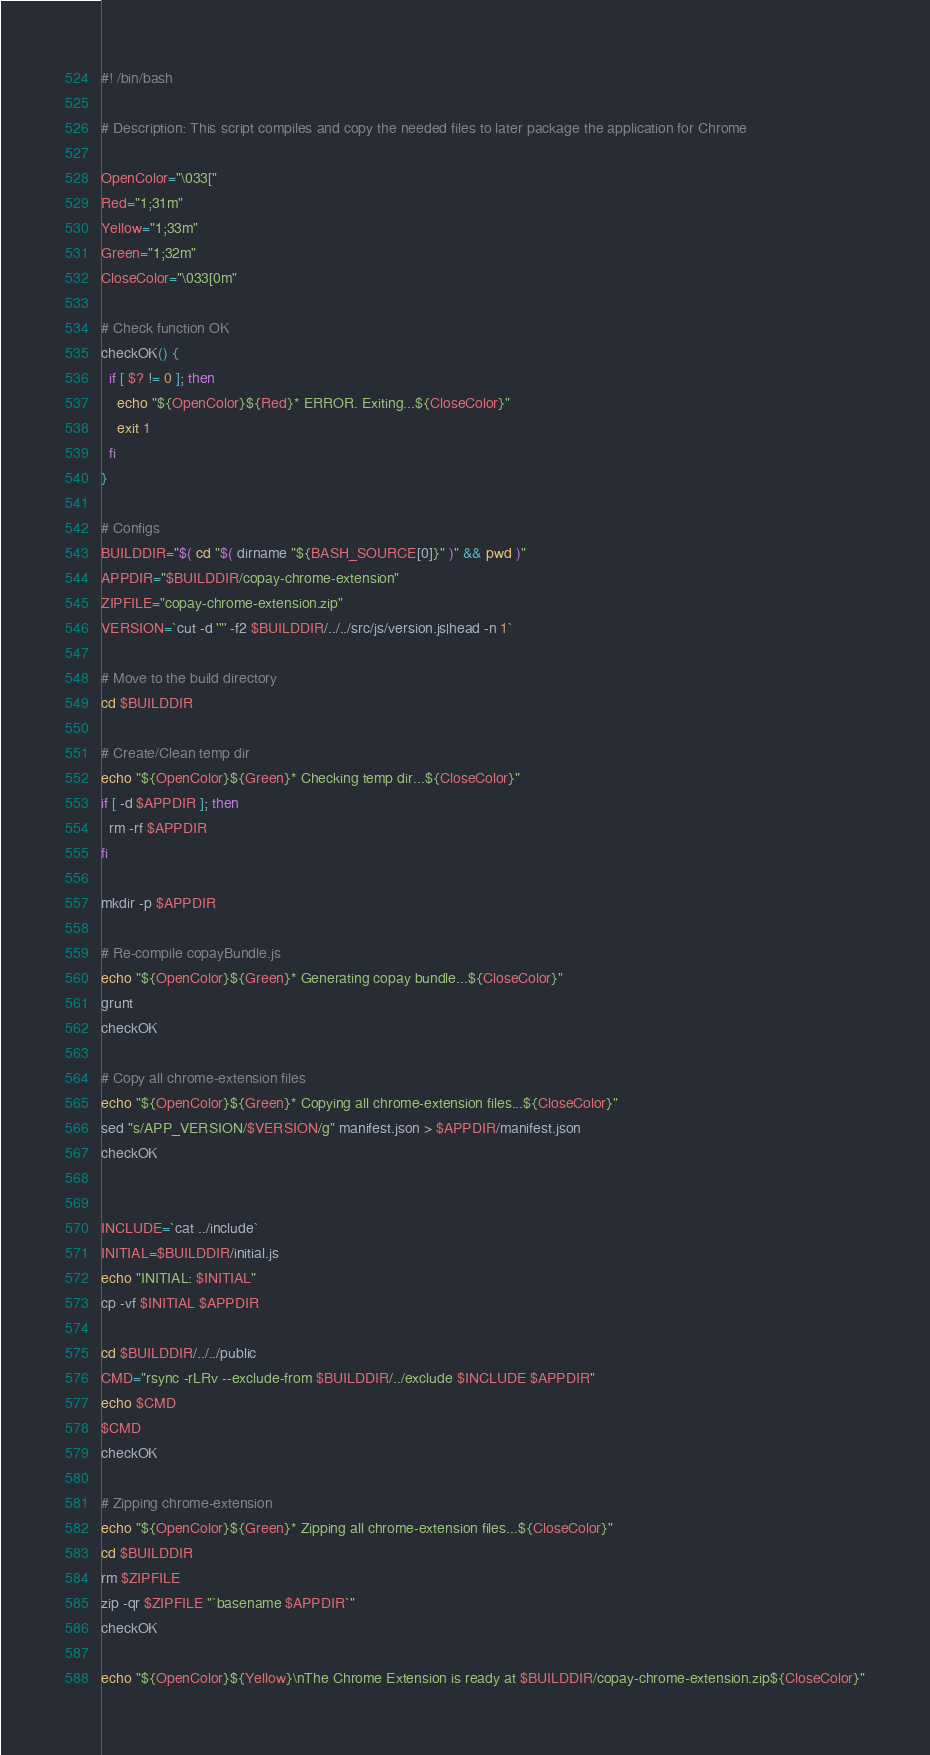<code> <loc_0><loc_0><loc_500><loc_500><_Bash_>#! /bin/bash

# Description: This script compiles and copy the needed files to later package the application for Chrome

OpenColor="\033["
Red="1;31m"
Yellow="1;33m"
Green="1;32m"
CloseColor="\033[0m"

# Check function OK
checkOK() {
  if [ $? != 0 ]; then
    echo "${OpenColor}${Red}* ERROR. Exiting...${CloseColor}"
    exit 1
  fi
}

# Configs
BUILDDIR="$( cd "$( dirname "${BASH_SOURCE[0]}" )" && pwd )"
APPDIR="$BUILDDIR/copay-chrome-extension"
ZIPFILE="copay-chrome-extension.zip"
VERSION=`cut -d '"' -f2 $BUILDDIR/../../src/js/version.js|head -n 1`

# Move to the build directory
cd $BUILDDIR

# Create/Clean temp dir
echo "${OpenColor}${Green}* Checking temp dir...${CloseColor}"
if [ -d $APPDIR ]; then
  rm -rf $APPDIR
fi

mkdir -p $APPDIR

# Re-compile copayBundle.js
echo "${OpenColor}${Green}* Generating copay bundle...${CloseColor}"
grunt
checkOK

# Copy all chrome-extension files
echo "${OpenColor}${Green}* Copying all chrome-extension files...${CloseColor}"
sed "s/APP_VERSION/$VERSION/g" manifest.json > $APPDIR/manifest.json
checkOK

 
INCLUDE=`cat ../include`
INITIAL=$BUILDDIR/initial.js
echo "INITIAL: $INITIAL"
cp -vf $INITIAL $APPDIR

cd $BUILDDIR/../../public
CMD="rsync -rLRv --exclude-from $BUILDDIR/../exclude $INCLUDE $APPDIR"
echo $CMD
$CMD
checkOK

# Zipping chrome-extension
echo "${OpenColor}${Green}* Zipping all chrome-extension files...${CloseColor}"
cd $BUILDDIR
rm $ZIPFILE
zip -qr $ZIPFILE "`basename $APPDIR`"
checkOK

echo "${OpenColor}${Yellow}\nThe Chrome Extension is ready at $BUILDDIR/copay-chrome-extension.zip${CloseColor}"
</code> 